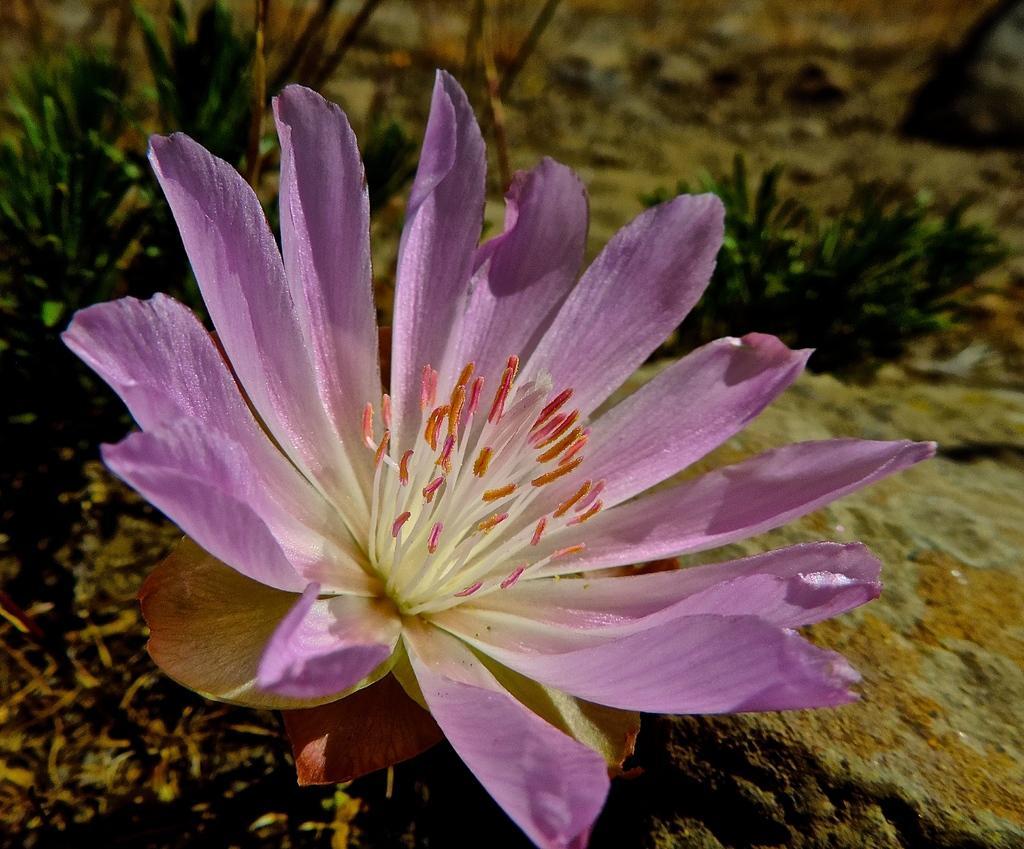Can you describe this image briefly? In this picture we can see a flower. Behind the flower, there are plants and blurred background. On the right side of the image, there is a rock. 